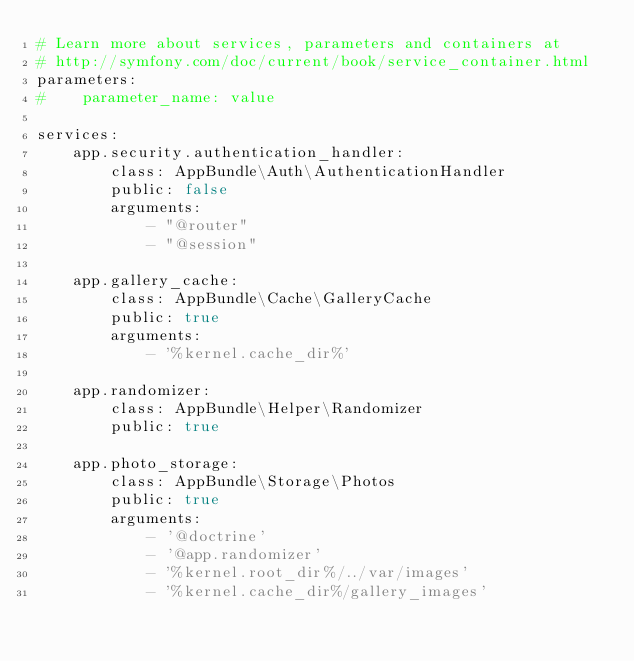Convert code to text. <code><loc_0><loc_0><loc_500><loc_500><_YAML_># Learn more about services, parameters and containers at
# http://symfony.com/doc/current/book/service_container.html
parameters:
#    parameter_name: value

services:
    app.security.authentication_handler:
        class: AppBundle\Auth\AuthenticationHandler
        public: false
        arguments:
            - "@router"
            - "@session"

    app.gallery_cache:
        class: AppBundle\Cache\GalleryCache
        public: true
        arguments:
            - '%kernel.cache_dir%'

    app.randomizer:
        class: AppBundle\Helper\Randomizer
        public: true

    app.photo_storage:
        class: AppBundle\Storage\Photos
        public: true
        arguments:
            - '@doctrine'
            - '@app.randomizer'
            - '%kernel.root_dir%/../var/images'
            - '%kernel.cache_dir%/gallery_images'
</code> 